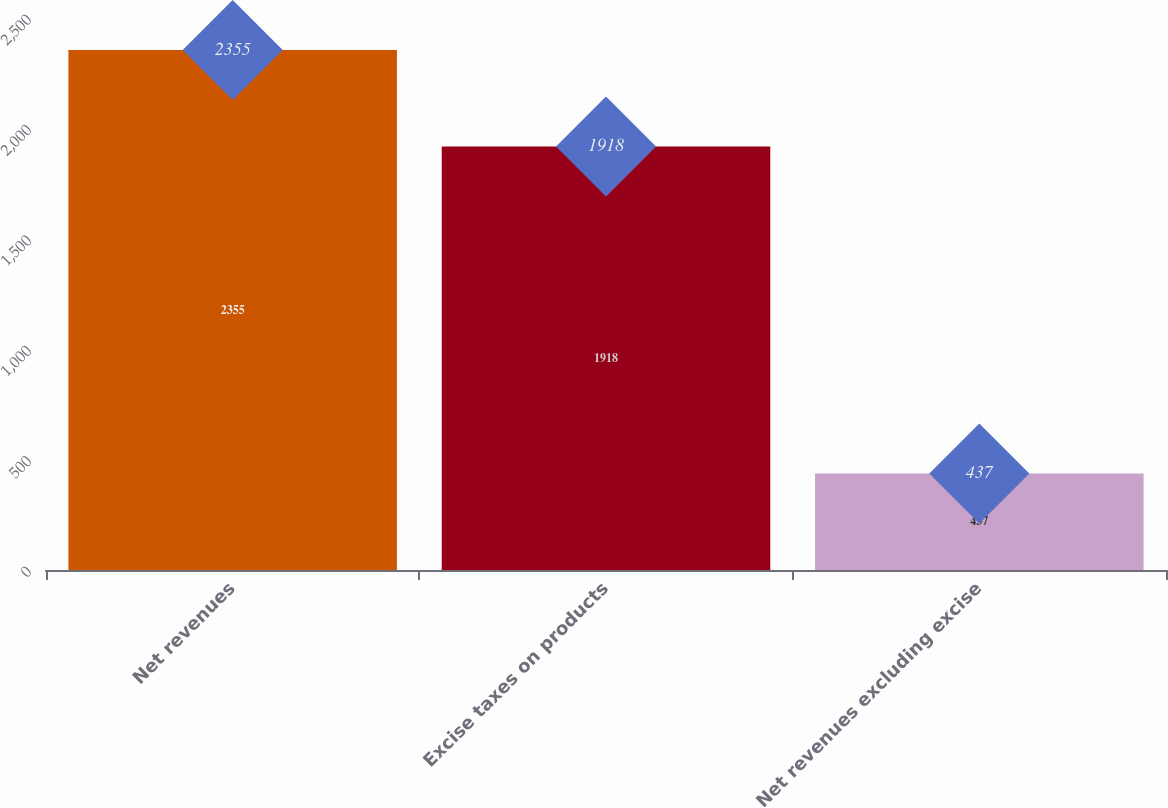<chart> <loc_0><loc_0><loc_500><loc_500><bar_chart><fcel>Net revenues<fcel>Excise taxes on products<fcel>Net revenues excluding excise<nl><fcel>2355<fcel>1918<fcel>437<nl></chart> 